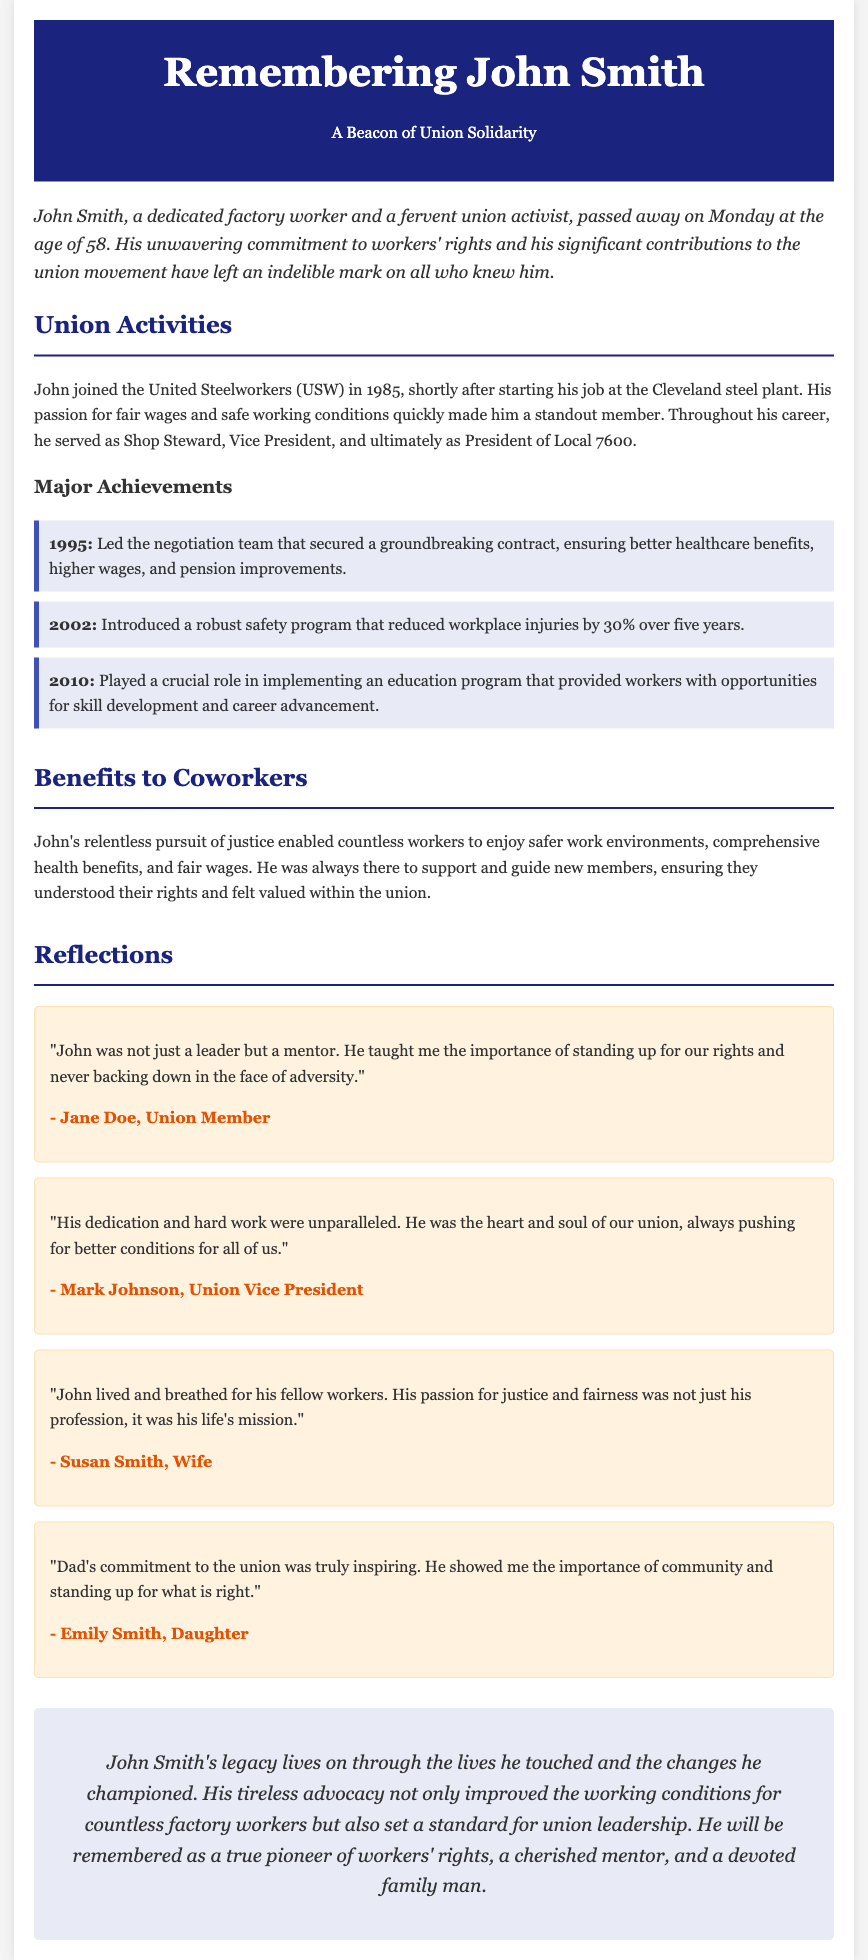What year did John join the United Steelworkers? John joined the United Steelworkers shortly after starting his job in 1985.
Answer: 1985 What position did John hold before becoming President of Local 7600? Before becoming President, John served as Vice President of Local 7600.
Answer: Vice President How much did workplace injuries reduce due to the safety program introduced by John? The safety program introduced by John reduced workplace injuries by 30% over five years.
Answer: 30% Who described John as "the heart and soul of our union"? Mark Johnson, Union Vice President, described John as "the heart and soul of our union."
Answer: Mark Johnson What was John's age at the time of his passing? John passed away at the age of 58.
Answer: 58 What was one of the major achievements of John in 1995? In 1995, John led the negotiation team that secured a groundbreaking contract.
Answer: Groundbreaking contract Who is quoted saying John taught them the importance of standing up for their rights? Jane Doe, a Union Member, is quoted saying this about John.
Answer: Jane Doe What is one word that characterizes John's commitment to workers? John's commitment to workers can be characterized as relentless.
Answer: Relentless What does John’s legacy include? John's legacy includes improved working conditions and a standard for union leadership.
Answer: Improved working conditions 